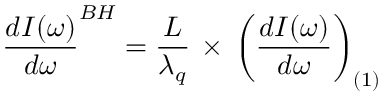<formula> <loc_0><loc_0><loc_500><loc_500>\frac { d I ( \omega ) } { d \omega } ^ { B H } = \frac { L } { \lambda _ { q } } \, \times \, \left ( \frac { d I ( \omega ) } { d \omega } \right ) _ { ( 1 ) }</formula> 